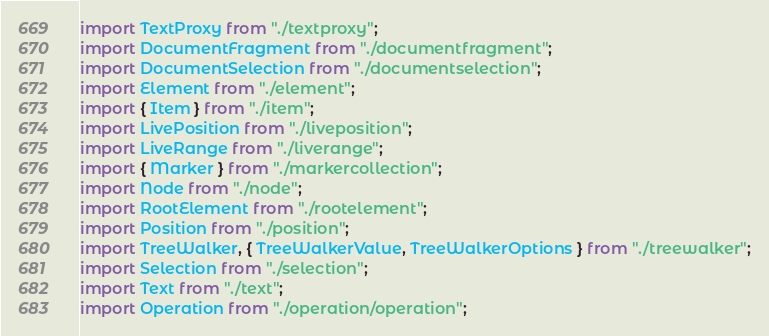Convert code to text. <code><loc_0><loc_0><loc_500><loc_500><_TypeScript_>import TextProxy from "./textproxy";
import DocumentFragment from "./documentfragment";
import DocumentSelection from "./documentselection";
import Element from "./element";
import { Item } from "./item";
import LivePosition from "./liveposition";
import LiveRange from "./liverange";
import { Marker } from "./markercollection";
import Node from "./node";
import RootElement from "./rootelement";
import Position from "./position";
import TreeWalker, { TreeWalkerValue, TreeWalkerOptions } from "./treewalker";
import Selection from "./selection";
import Text from "./text";
import Operation from "./operation/operation";
</code> 